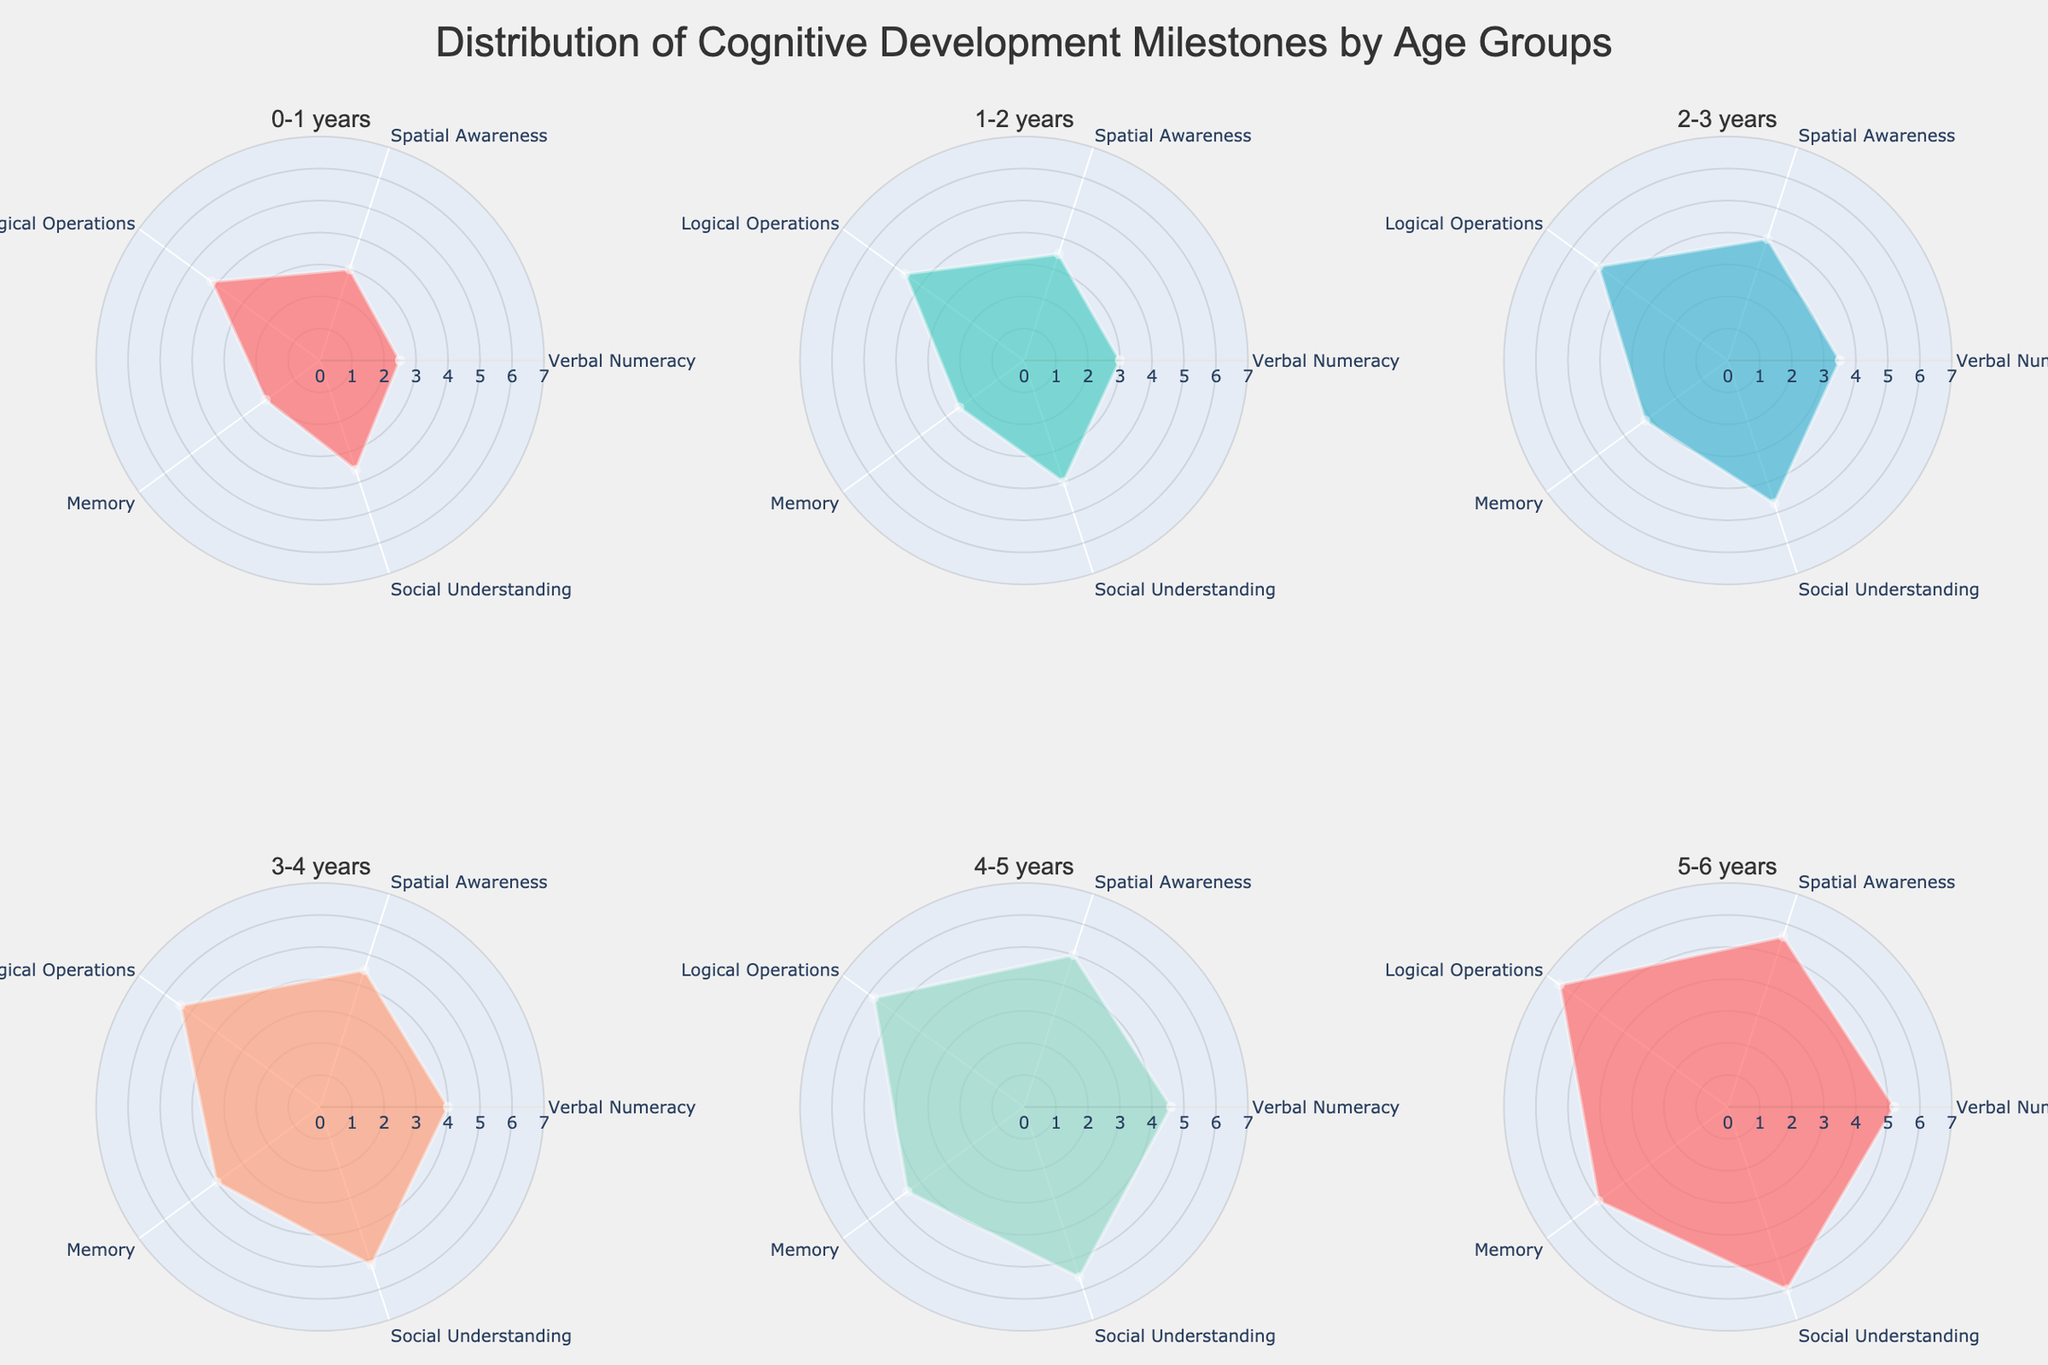What is the title of the figure? The title is usually placed at the top of the figure which provides an overall description of the data. In this case, the title is located at the top center.
Answer: Distribution of Cognitive Development Milestones by Age Groups What color is used to represent the 0-1 years age group? The colors for each age group are consistent across all subplots. The 0-1 years age group is represented by the first color in the list of colors used.
Answer: Red How many cognitive development categories are tracked for each age group? Each subplot or polar chart shows data points for several categories. By counting the unique labels on the theta axis in any subplot, you can determine the number of categories.
Answer: Five Which age group has the highest value for Verbal Numeracy? Look at the values plotted for the Verbal Numeracy category in all subplots and identify which one is the highest.
Answer: 5-6 years Compare the Memory development scores of 2-3 years versus 4-5 years. Which one is higher? Identify the Memory scores for the 2-3 years and 4-5 years age groups and compare the numerical values.
Answer: 4-5 years What is the difference in Logical Operations scores between 3-4 years and 5-6 years age groups? Find the Logical Operations score for both age groups and subtract the lower score from the higher score.
Answer: 5.0 - 4.0 = 1.0 On average, which age group has the highest overall cognitive development score? To find this out, sum up the scores for each category in each age group and then calculate the average. Determine which age group has the highest average score.
Answer: 5-6 years Which cognitive development category shows the most noticeable improvement from 0-1 years to 1-2 years? Compare the data for each category between the two age groups and identify the category with the greatest increase in scores.
Answer: Spatial Awareness Among all age groups, which age group's Social Understanding score is the lowest? Check all subplots, focusing on the Social Understanding scores, and identify the lowest value.
Answer: 0-1 years 